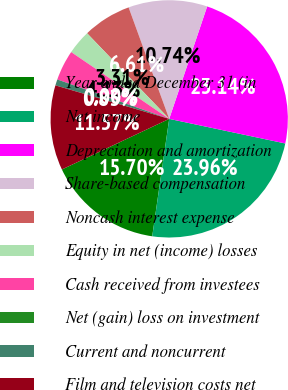Convert chart. <chart><loc_0><loc_0><loc_500><loc_500><pie_chart><fcel>Year ended December 31 (in<fcel>Net income<fcel>Depreciation and amortization<fcel>Share-based compensation<fcel>Noncash interest expense<fcel>Equity in net (income) losses<fcel>Cash received from investees<fcel>Net (gain) loss on investment<fcel>Current and noncurrent<fcel>Film and television costs net<nl><fcel>15.7%<fcel>23.96%<fcel>23.14%<fcel>10.74%<fcel>6.61%<fcel>3.31%<fcel>4.13%<fcel>0.0%<fcel>0.83%<fcel>11.57%<nl></chart> 